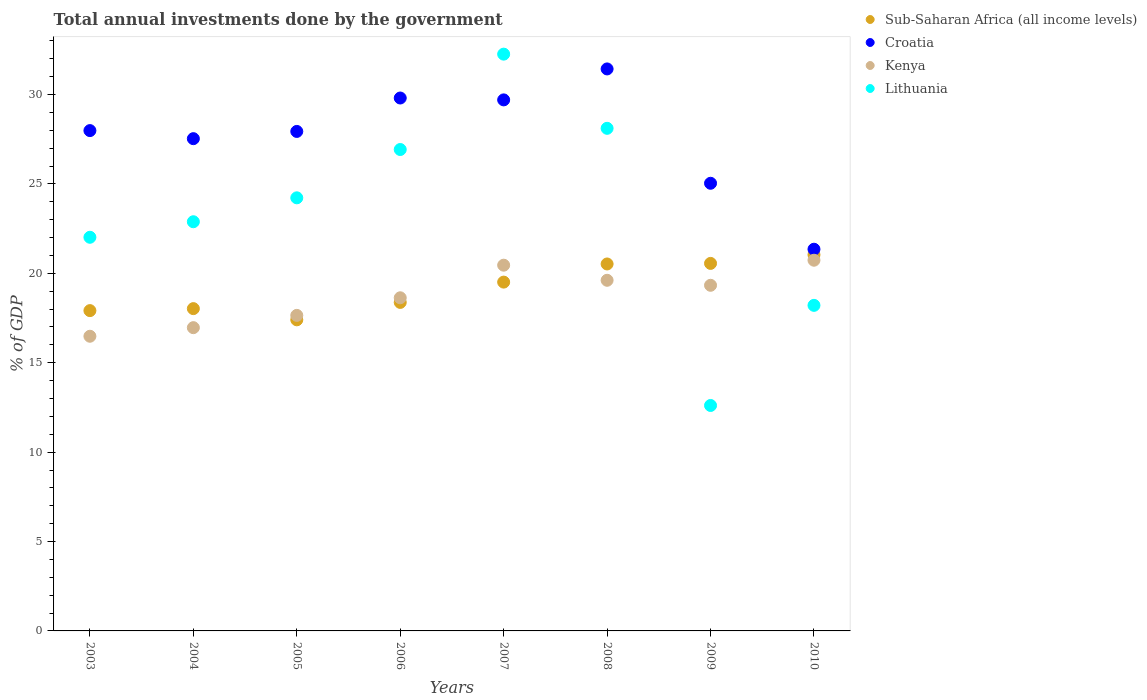How many different coloured dotlines are there?
Provide a short and direct response. 4. What is the total annual investments done by the government in Kenya in 2007?
Your response must be concise. 20.46. Across all years, what is the maximum total annual investments done by the government in Croatia?
Ensure brevity in your answer.  31.43. Across all years, what is the minimum total annual investments done by the government in Lithuania?
Make the answer very short. 12.61. In which year was the total annual investments done by the government in Lithuania maximum?
Give a very brief answer. 2007. What is the total total annual investments done by the government in Lithuania in the graph?
Ensure brevity in your answer.  187.25. What is the difference between the total annual investments done by the government in Croatia in 2008 and that in 2009?
Ensure brevity in your answer.  6.4. What is the difference between the total annual investments done by the government in Lithuania in 2003 and the total annual investments done by the government in Kenya in 2008?
Your answer should be compact. 2.41. What is the average total annual investments done by the government in Croatia per year?
Your answer should be compact. 27.6. In the year 2010, what is the difference between the total annual investments done by the government in Sub-Saharan Africa (all income levels) and total annual investments done by the government in Kenya?
Give a very brief answer. 0.3. What is the ratio of the total annual investments done by the government in Sub-Saharan Africa (all income levels) in 2006 to that in 2010?
Offer a very short reply. 0.87. Is the total annual investments done by the government in Kenya in 2005 less than that in 2008?
Your answer should be compact. Yes. Is the difference between the total annual investments done by the government in Sub-Saharan Africa (all income levels) in 2004 and 2008 greater than the difference between the total annual investments done by the government in Kenya in 2004 and 2008?
Offer a very short reply. Yes. What is the difference between the highest and the second highest total annual investments done by the government in Lithuania?
Make the answer very short. 4.15. What is the difference between the highest and the lowest total annual investments done by the government in Lithuania?
Offer a very short reply. 19.65. In how many years, is the total annual investments done by the government in Lithuania greater than the average total annual investments done by the government in Lithuania taken over all years?
Your answer should be compact. 4. Is it the case that in every year, the sum of the total annual investments done by the government in Kenya and total annual investments done by the government in Sub-Saharan Africa (all income levels)  is greater than the sum of total annual investments done by the government in Lithuania and total annual investments done by the government in Croatia?
Offer a very short reply. No. Is it the case that in every year, the sum of the total annual investments done by the government in Sub-Saharan Africa (all income levels) and total annual investments done by the government in Kenya  is greater than the total annual investments done by the government in Croatia?
Your answer should be very brief. Yes. Does the total annual investments done by the government in Lithuania monotonically increase over the years?
Provide a succinct answer. No. Is the total annual investments done by the government in Lithuania strictly less than the total annual investments done by the government in Croatia over the years?
Provide a succinct answer. No. How many years are there in the graph?
Make the answer very short. 8. Does the graph contain grids?
Provide a succinct answer. No. Where does the legend appear in the graph?
Give a very brief answer. Top right. How are the legend labels stacked?
Offer a very short reply. Vertical. What is the title of the graph?
Ensure brevity in your answer.  Total annual investments done by the government. Does "Sint Maarten (Dutch part)" appear as one of the legend labels in the graph?
Your answer should be very brief. No. What is the label or title of the Y-axis?
Your response must be concise. % of GDP. What is the % of GDP of Sub-Saharan Africa (all income levels) in 2003?
Provide a succinct answer. 17.92. What is the % of GDP of Croatia in 2003?
Ensure brevity in your answer.  27.99. What is the % of GDP of Kenya in 2003?
Make the answer very short. 16.48. What is the % of GDP in Lithuania in 2003?
Offer a very short reply. 22.02. What is the % of GDP in Sub-Saharan Africa (all income levels) in 2004?
Offer a very short reply. 18.03. What is the % of GDP of Croatia in 2004?
Your response must be concise. 27.53. What is the % of GDP of Kenya in 2004?
Offer a terse response. 16.96. What is the % of GDP in Lithuania in 2004?
Ensure brevity in your answer.  22.89. What is the % of GDP of Sub-Saharan Africa (all income levels) in 2005?
Keep it short and to the point. 17.4. What is the % of GDP in Croatia in 2005?
Keep it short and to the point. 27.94. What is the % of GDP in Kenya in 2005?
Make the answer very short. 17.65. What is the % of GDP of Lithuania in 2005?
Provide a succinct answer. 24.22. What is the % of GDP of Sub-Saharan Africa (all income levels) in 2006?
Give a very brief answer. 18.37. What is the % of GDP of Croatia in 2006?
Keep it short and to the point. 29.81. What is the % of GDP of Kenya in 2006?
Ensure brevity in your answer.  18.63. What is the % of GDP of Lithuania in 2006?
Provide a short and direct response. 26.93. What is the % of GDP in Sub-Saharan Africa (all income levels) in 2007?
Give a very brief answer. 19.51. What is the % of GDP in Croatia in 2007?
Your response must be concise. 29.7. What is the % of GDP of Kenya in 2007?
Provide a short and direct response. 20.46. What is the % of GDP in Lithuania in 2007?
Keep it short and to the point. 32.26. What is the % of GDP of Sub-Saharan Africa (all income levels) in 2008?
Offer a very short reply. 20.53. What is the % of GDP in Croatia in 2008?
Your answer should be very brief. 31.43. What is the % of GDP in Kenya in 2008?
Make the answer very short. 19.61. What is the % of GDP of Lithuania in 2008?
Provide a short and direct response. 28.11. What is the % of GDP of Sub-Saharan Africa (all income levels) in 2009?
Your answer should be very brief. 20.56. What is the % of GDP in Croatia in 2009?
Give a very brief answer. 25.04. What is the % of GDP in Kenya in 2009?
Give a very brief answer. 19.33. What is the % of GDP of Lithuania in 2009?
Your answer should be very brief. 12.61. What is the % of GDP of Sub-Saharan Africa (all income levels) in 2010?
Keep it short and to the point. 21.04. What is the % of GDP in Croatia in 2010?
Offer a terse response. 21.35. What is the % of GDP in Kenya in 2010?
Provide a succinct answer. 20.73. What is the % of GDP of Lithuania in 2010?
Your answer should be very brief. 18.21. Across all years, what is the maximum % of GDP of Sub-Saharan Africa (all income levels)?
Ensure brevity in your answer.  21.04. Across all years, what is the maximum % of GDP of Croatia?
Your response must be concise. 31.43. Across all years, what is the maximum % of GDP of Kenya?
Your answer should be compact. 20.73. Across all years, what is the maximum % of GDP in Lithuania?
Offer a very short reply. 32.26. Across all years, what is the minimum % of GDP of Sub-Saharan Africa (all income levels)?
Offer a terse response. 17.4. Across all years, what is the minimum % of GDP in Croatia?
Your answer should be very brief. 21.35. Across all years, what is the minimum % of GDP of Kenya?
Your answer should be compact. 16.48. Across all years, what is the minimum % of GDP of Lithuania?
Ensure brevity in your answer.  12.61. What is the total % of GDP in Sub-Saharan Africa (all income levels) in the graph?
Provide a short and direct response. 153.35. What is the total % of GDP of Croatia in the graph?
Offer a very short reply. 220.79. What is the total % of GDP in Kenya in the graph?
Your answer should be very brief. 149.87. What is the total % of GDP of Lithuania in the graph?
Provide a succinct answer. 187.25. What is the difference between the % of GDP of Sub-Saharan Africa (all income levels) in 2003 and that in 2004?
Provide a short and direct response. -0.11. What is the difference between the % of GDP in Croatia in 2003 and that in 2004?
Give a very brief answer. 0.45. What is the difference between the % of GDP of Kenya in 2003 and that in 2004?
Give a very brief answer. -0.48. What is the difference between the % of GDP in Lithuania in 2003 and that in 2004?
Offer a very short reply. -0.87. What is the difference between the % of GDP of Sub-Saharan Africa (all income levels) in 2003 and that in 2005?
Keep it short and to the point. 0.52. What is the difference between the % of GDP in Croatia in 2003 and that in 2005?
Provide a succinct answer. 0.05. What is the difference between the % of GDP of Kenya in 2003 and that in 2005?
Provide a succinct answer. -1.17. What is the difference between the % of GDP in Lithuania in 2003 and that in 2005?
Your answer should be very brief. -2.21. What is the difference between the % of GDP of Sub-Saharan Africa (all income levels) in 2003 and that in 2006?
Your answer should be very brief. -0.46. What is the difference between the % of GDP of Croatia in 2003 and that in 2006?
Make the answer very short. -1.82. What is the difference between the % of GDP in Kenya in 2003 and that in 2006?
Your answer should be very brief. -2.15. What is the difference between the % of GDP in Lithuania in 2003 and that in 2006?
Keep it short and to the point. -4.91. What is the difference between the % of GDP of Sub-Saharan Africa (all income levels) in 2003 and that in 2007?
Make the answer very short. -1.59. What is the difference between the % of GDP in Croatia in 2003 and that in 2007?
Ensure brevity in your answer.  -1.72. What is the difference between the % of GDP in Kenya in 2003 and that in 2007?
Your response must be concise. -3.97. What is the difference between the % of GDP of Lithuania in 2003 and that in 2007?
Offer a very short reply. -10.24. What is the difference between the % of GDP of Sub-Saharan Africa (all income levels) in 2003 and that in 2008?
Make the answer very short. -2.61. What is the difference between the % of GDP in Croatia in 2003 and that in 2008?
Your response must be concise. -3.45. What is the difference between the % of GDP in Kenya in 2003 and that in 2008?
Keep it short and to the point. -3.13. What is the difference between the % of GDP in Lithuania in 2003 and that in 2008?
Provide a succinct answer. -6.09. What is the difference between the % of GDP in Sub-Saharan Africa (all income levels) in 2003 and that in 2009?
Offer a very short reply. -2.64. What is the difference between the % of GDP of Croatia in 2003 and that in 2009?
Offer a terse response. 2.95. What is the difference between the % of GDP in Kenya in 2003 and that in 2009?
Your response must be concise. -2.85. What is the difference between the % of GDP in Lithuania in 2003 and that in 2009?
Keep it short and to the point. 9.41. What is the difference between the % of GDP in Sub-Saharan Africa (all income levels) in 2003 and that in 2010?
Give a very brief answer. -3.12. What is the difference between the % of GDP of Croatia in 2003 and that in 2010?
Offer a terse response. 6.64. What is the difference between the % of GDP of Kenya in 2003 and that in 2010?
Offer a terse response. -4.25. What is the difference between the % of GDP in Lithuania in 2003 and that in 2010?
Offer a terse response. 3.81. What is the difference between the % of GDP in Sub-Saharan Africa (all income levels) in 2004 and that in 2005?
Your answer should be compact. 0.63. What is the difference between the % of GDP of Croatia in 2004 and that in 2005?
Offer a very short reply. -0.4. What is the difference between the % of GDP of Kenya in 2004 and that in 2005?
Give a very brief answer. -0.69. What is the difference between the % of GDP in Lithuania in 2004 and that in 2005?
Keep it short and to the point. -1.34. What is the difference between the % of GDP of Sub-Saharan Africa (all income levels) in 2004 and that in 2006?
Offer a terse response. -0.35. What is the difference between the % of GDP of Croatia in 2004 and that in 2006?
Give a very brief answer. -2.27. What is the difference between the % of GDP of Kenya in 2004 and that in 2006?
Offer a terse response. -1.67. What is the difference between the % of GDP in Lithuania in 2004 and that in 2006?
Make the answer very short. -4.04. What is the difference between the % of GDP of Sub-Saharan Africa (all income levels) in 2004 and that in 2007?
Offer a terse response. -1.48. What is the difference between the % of GDP in Croatia in 2004 and that in 2007?
Your response must be concise. -2.17. What is the difference between the % of GDP in Kenya in 2004 and that in 2007?
Provide a succinct answer. -3.49. What is the difference between the % of GDP of Lithuania in 2004 and that in 2007?
Make the answer very short. -9.37. What is the difference between the % of GDP of Sub-Saharan Africa (all income levels) in 2004 and that in 2008?
Give a very brief answer. -2.5. What is the difference between the % of GDP in Croatia in 2004 and that in 2008?
Offer a terse response. -3.9. What is the difference between the % of GDP of Kenya in 2004 and that in 2008?
Offer a terse response. -2.65. What is the difference between the % of GDP in Lithuania in 2004 and that in 2008?
Offer a very short reply. -5.23. What is the difference between the % of GDP in Sub-Saharan Africa (all income levels) in 2004 and that in 2009?
Offer a terse response. -2.53. What is the difference between the % of GDP in Croatia in 2004 and that in 2009?
Make the answer very short. 2.5. What is the difference between the % of GDP of Kenya in 2004 and that in 2009?
Your answer should be compact. -2.37. What is the difference between the % of GDP in Lithuania in 2004 and that in 2009?
Your answer should be very brief. 10.28. What is the difference between the % of GDP in Sub-Saharan Africa (all income levels) in 2004 and that in 2010?
Offer a terse response. -3.01. What is the difference between the % of GDP in Croatia in 2004 and that in 2010?
Ensure brevity in your answer.  6.18. What is the difference between the % of GDP of Kenya in 2004 and that in 2010?
Your answer should be compact. -3.77. What is the difference between the % of GDP of Lithuania in 2004 and that in 2010?
Your answer should be very brief. 4.68. What is the difference between the % of GDP of Sub-Saharan Africa (all income levels) in 2005 and that in 2006?
Give a very brief answer. -0.97. What is the difference between the % of GDP of Croatia in 2005 and that in 2006?
Keep it short and to the point. -1.87. What is the difference between the % of GDP of Kenya in 2005 and that in 2006?
Your response must be concise. -0.98. What is the difference between the % of GDP of Lithuania in 2005 and that in 2006?
Offer a very short reply. -2.7. What is the difference between the % of GDP in Sub-Saharan Africa (all income levels) in 2005 and that in 2007?
Offer a very short reply. -2.11. What is the difference between the % of GDP of Croatia in 2005 and that in 2007?
Your response must be concise. -1.76. What is the difference between the % of GDP in Kenya in 2005 and that in 2007?
Keep it short and to the point. -2.81. What is the difference between the % of GDP in Lithuania in 2005 and that in 2007?
Provide a succinct answer. -8.04. What is the difference between the % of GDP of Sub-Saharan Africa (all income levels) in 2005 and that in 2008?
Make the answer very short. -3.12. What is the difference between the % of GDP in Croatia in 2005 and that in 2008?
Your answer should be compact. -3.5. What is the difference between the % of GDP in Kenya in 2005 and that in 2008?
Make the answer very short. -1.96. What is the difference between the % of GDP in Lithuania in 2005 and that in 2008?
Keep it short and to the point. -3.89. What is the difference between the % of GDP in Sub-Saharan Africa (all income levels) in 2005 and that in 2009?
Keep it short and to the point. -3.16. What is the difference between the % of GDP of Croatia in 2005 and that in 2009?
Make the answer very short. 2.9. What is the difference between the % of GDP of Kenya in 2005 and that in 2009?
Provide a succinct answer. -1.68. What is the difference between the % of GDP of Lithuania in 2005 and that in 2009?
Your answer should be compact. 11.62. What is the difference between the % of GDP in Sub-Saharan Africa (all income levels) in 2005 and that in 2010?
Your answer should be compact. -3.64. What is the difference between the % of GDP of Croatia in 2005 and that in 2010?
Offer a terse response. 6.59. What is the difference between the % of GDP in Kenya in 2005 and that in 2010?
Make the answer very short. -3.09. What is the difference between the % of GDP in Lithuania in 2005 and that in 2010?
Keep it short and to the point. 6.01. What is the difference between the % of GDP of Sub-Saharan Africa (all income levels) in 2006 and that in 2007?
Offer a terse response. -1.14. What is the difference between the % of GDP in Croatia in 2006 and that in 2007?
Your answer should be very brief. 0.1. What is the difference between the % of GDP of Kenya in 2006 and that in 2007?
Your answer should be compact. -1.82. What is the difference between the % of GDP of Lithuania in 2006 and that in 2007?
Give a very brief answer. -5.33. What is the difference between the % of GDP in Sub-Saharan Africa (all income levels) in 2006 and that in 2008?
Make the answer very short. -2.15. What is the difference between the % of GDP in Croatia in 2006 and that in 2008?
Provide a succinct answer. -1.63. What is the difference between the % of GDP of Kenya in 2006 and that in 2008?
Give a very brief answer. -0.98. What is the difference between the % of GDP of Lithuania in 2006 and that in 2008?
Give a very brief answer. -1.19. What is the difference between the % of GDP in Sub-Saharan Africa (all income levels) in 2006 and that in 2009?
Give a very brief answer. -2.18. What is the difference between the % of GDP in Croatia in 2006 and that in 2009?
Offer a terse response. 4.77. What is the difference between the % of GDP in Kenya in 2006 and that in 2009?
Make the answer very short. -0.7. What is the difference between the % of GDP in Lithuania in 2006 and that in 2009?
Your answer should be very brief. 14.32. What is the difference between the % of GDP of Sub-Saharan Africa (all income levels) in 2006 and that in 2010?
Offer a terse response. -2.66. What is the difference between the % of GDP of Croatia in 2006 and that in 2010?
Offer a terse response. 8.46. What is the difference between the % of GDP of Kenya in 2006 and that in 2010?
Offer a very short reply. -2.1. What is the difference between the % of GDP of Lithuania in 2006 and that in 2010?
Provide a short and direct response. 8.72. What is the difference between the % of GDP in Sub-Saharan Africa (all income levels) in 2007 and that in 2008?
Provide a succinct answer. -1.01. What is the difference between the % of GDP in Croatia in 2007 and that in 2008?
Your answer should be very brief. -1.73. What is the difference between the % of GDP of Kenya in 2007 and that in 2008?
Your answer should be compact. 0.84. What is the difference between the % of GDP in Lithuania in 2007 and that in 2008?
Your answer should be compact. 4.15. What is the difference between the % of GDP in Sub-Saharan Africa (all income levels) in 2007 and that in 2009?
Give a very brief answer. -1.05. What is the difference between the % of GDP of Croatia in 2007 and that in 2009?
Provide a succinct answer. 4.66. What is the difference between the % of GDP in Kenya in 2007 and that in 2009?
Offer a terse response. 1.12. What is the difference between the % of GDP in Lithuania in 2007 and that in 2009?
Provide a short and direct response. 19.65. What is the difference between the % of GDP of Sub-Saharan Africa (all income levels) in 2007 and that in 2010?
Your response must be concise. -1.53. What is the difference between the % of GDP in Croatia in 2007 and that in 2010?
Give a very brief answer. 8.35. What is the difference between the % of GDP of Kenya in 2007 and that in 2010?
Keep it short and to the point. -0.28. What is the difference between the % of GDP in Lithuania in 2007 and that in 2010?
Offer a terse response. 14.05. What is the difference between the % of GDP in Sub-Saharan Africa (all income levels) in 2008 and that in 2009?
Your response must be concise. -0.03. What is the difference between the % of GDP of Croatia in 2008 and that in 2009?
Keep it short and to the point. 6.4. What is the difference between the % of GDP of Kenya in 2008 and that in 2009?
Your answer should be very brief. 0.28. What is the difference between the % of GDP of Lithuania in 2008 and that in 2009?
Provide a short and direct response. 15.5. What is the difference between the % of GDP in Sub-Saharan Africa (all income levels) in 2008 and that in 2010?
Provide a short and direct response. -0.51. What is the difference between the % of GDP in Croatia in 2008 and that in 2010?
Offer a terse response. 10.08. What is the difference between the % of GDP of Kenya in 2008 and that in 2010?
Give a very brief answer. -1.12. What is the difference between the % of GDP in Lithuania in 2008 and that in 2010?
Provide a succinct answer. 9.9. What is the difference between the % of GDP of Sub-Saharan Africa (all income levels) in 2009 and that in 2010?
Give a very brief answer. -0.48. What is the difference between the % of GDP in Croatia in 2009 and that in 2010?
Your answer should be compact. 3.69. What is the difference between the % of GDP of Kenya in 2009 and that in 2010?
Your response must be concise. -1.4. What is the difference between the % of GDP of Lithuania in 2009 and that in 2010?
Provide a short and direct response. -5.6. What is the difference between the % of GDP of Sub-Saharan Africa (all income levels) in 2003 and the % of GDP of Croatia in 2004?
Your answer should be very brief. -9.62. What is the difference between the % of GDP of Sub-Saharan Africa (all income levels) in 2003 and the % of GDP of Kenya in 2004?
Ensure brevity in your answer.  0.95. What is the difference between the % of GDP of Sub-Saharan Africa (all income levels) in 2003 and the % of GDP of Lithuania in 2004?
Your answer should be very brief. -4.97. What is the difference between the % of GDP of Croatia in 2003 and the % of GDP of Kenya in 2004?
Your response must be concise. 11.02. What is the difference between the % of GDP in Croatia in 2003 and the % of GDP in Lithuania in 2004?
Ensure brevity in your answer.  5.1. What is the difference between the % of GDP of Kenya in 2003 and the % of GDP of Lithuania in 2004?
Your answer should be very brief. -6.41. What is the difference between the % of GDP of Sub-Saharan Africa (all income levels) in 2003 and the % of GDP of Croatia in 2005?
Make the answer very short. -10.02. What is the difference between the % of GDP in Sub-Saharan Africa (all income levels) in 2003 and the % of GDP in Kenya in 2005?
Make the answer very short. 0.27. What is the difference between the % of GDP of Sub-Saharan Africa (all income levels) in 2003 and the % of GDP of Lithuania in 2005?
Your response must be concise. -6.31. What is the difference between the % of GDP in Croatia in 2003 and the % of GDP in Kenya in 2005?
Your response must be concise. 10.34. What is the difference between the % of GDP of Croatia in 2003 and the % of GDP of Lithuania in 2005?
Ensure brevity in your answer.  3.76. What is the difference between the % of GDP of Kenya in 2003 and the % of GDP of Lithuania in 2005?
Give a very brief answer. -7.74. What is the difference between the % of GDP in Sub-Saharan Africa (all income levels) in 2003 and the % of GDP in Croatia in 2006?
Offer a terse response. -11.89. What is the difference between the % of GDP of Sub-Saharan Africa (all income levels) in 2003 and the % of GDP of Kenya in 2006?
Offer a terse response. -0.72. What is the difference between the % of GDP in Sub-Saharan Africa (all income levels) in 2003 and the % of GDP in Lithuania in 2006?
Offer a very short reply. -9.01. What is the difference between the % of GDP of Croatia in 2003 and the % of GDP of Kenya in 2006?
Your answer should be very brief. 9.35. What is the difference between the % of GDP of Croatia in 2003 and the % of GDP of Lithuania in 2006?
Offer a very short reply. 1.06. What is the difference between the % of GDP in Kenya in 2003 and the % of GDP in Lithuania in 2006?
Offer a very short reply. -10.44. What is the difference between the % of GDP in Sub-Saharan Africa (all income levels) in 2003 and the % of GDP in Croatia in 2007?
Your answer should be compact. -11.79. What is the difference between the % of GDP of Sub-Saharan Africa (all income levels) in 2003 and the % of GDP of Kenya in 2007?
Your answer should be compact. -2.54. What is the difference between the % of GDP in Sub-Saharan Africa (all income levels) in 2003 and the % of GDP in Lithuania in 2007?
Make the answer very short. -14.35. What is the difference between the % of GDP in Croatia in 2003 and the % of GDP in Kenya in 2007?
Your answer should be compact. 7.53. What is the difference between the % of GDP in Croatia in 2003 and the % of GDP in Lithuania in 2007?
Ensure brevity in your answer.  -4.28. What is the difference between the % of GDP in Kenya in 2003 and the % of GDP in Lithuania in 2007?
Provide a succinct answer. -15.78. What is the difference between the % of GDP in Sub-Saharan Africa (all income levels) in 2003 and the % of GDP in Croatia in 2008?
Make the answer very short. -13.52. What is the difference between the % of GDP in Sub-Saharan Africa (all income levels) in 2003 and the % of GDP in Kenya in 2008?
Provide a succinct answer. -1.7. What is the difference between the % of GDP of Sub-Saharan Africa (all income levels) in 2003 and the % of GDP of Lithuania in 2008?
Provide a succinct answer. -10.2. What is the difference between the % of GDP in Croatia in 2003 and the % of GDP in Kenya in 2008?
Provide a short and direct response. 8.37. What is the difference between the % of GDP of Croatia in 2003 and the % of GDP of Lithuania in 2008?
Ensure brevity in your answer.  -0.13. What is the difference between the % of GDP of Kenya in 2003 and the % of GDP of Lithuania in 2008?
Keep it short and to the point. -11.63. What is the difference between the % of GDP of Sub-Saharan Africa (all income levels) in 2003 and the % of GDP of Croatia in 2009?
Offer a terse response. -7.12. What is the difference between the % of GDP in Sub-Saharan Africa (all income levels) in 2003 and the % of GDP in Kenya in 2009?
Provide a short and direct response. -1.42. What is the difference between the % of GDP of Sub-Saharan Africa (all income levels) in 2003 and the % of GDP of Lithuania in 2009?
Ensure brevity in your answer.  5.31. What is the difference between the % of GDP in Croatia in 2003 and the % of GDP in Kenya in 2009?
Your response must be concise. 8.65. What is the difference between the % of GDP of Croatia in 2003 and the % of GDP of Lithuania in 2009?
Provide a short and direct response. 15.38. What is the difference between the % of GDP in Kenya in 2003 and the % of GDP in Lithuania in 2009?
Your response must be concise. 3.87. What is the difference between the % of GDP in Sub-Saharan Africa (all income levels) in 2003 and the % of GDP in Croatia in 2010?
Offer a terse response. -3.43. What is the difference between the % of GDP of Sub-Saharan Africa (all income levels) in 2003 and the % of GDP of Kenya in 2010?
Your response must be concise. -2.82. What is the difference between the % of GDP in Sub-Saharan Africa (all income levels) in 2003 and the % of GDP in Lithuania in 2010?
Ensure brevity in your answer.  -0.29. What is the difference between the % of GDP in Croatia in 2003 and the % of GDP in Kenya in 2010?
Provide a short and direct response. 7.25. What is the difference between the % of GDP in Croatia in 2003 and the % of GDP in Lithuania in 2010?
Your answer should be very brief. 9.78. What is the difference between the % of GDP of Kenya in 2003 and the % of GDP of Lithuania in 2010?
Your response must be concise. -1.73. What is the difference between the % of GDP of Sub-Saharan Africa (all income levels) in 2004 and the % of GDP of Croatia in 2005?
Give a very brief answer. -9.91. What is the difference between the % of GDP in Sub-Saharan Africa (all income levels) in 2004 and the % of GDP in Kenya in 2005?
Offer a terse response. 0.38. What is the difference between the % of GDP in Sub-Saharan Africa (all income levels) in 2004 and the % of GDP in Lithuania in 2005?
Provide a short and direct response. -6.2. What is the difference between the % of GDP of Croatia in 2004 and the % of GDP of Kenya in 2005?
Make the answer very short. 9.88. What is the difference between the % of GDP of Croatia in 2004 and the % of GDP of Lithuania in 2005?
Give a very brief answer. 3.31. What is the difference between the % of GDP of Kenya in 2004 and the % of GDP of Lithuania in 2005?
Provide a short and direct response. -7.26. What is the difference between the % of GDP of Sub-Saharan Africa (all income levels) in 2004 and the % of GDP of Croatia in 2006?
Your answer should be compact. -11.78. What is the difference between the % of GDP in Sub-Saharan Africa (all income levels) in 2004 and the % of GDP in Kenya in 2006?
Ensure brevity in your answer.  -0.61. What is the difference between the % of GDP of Sub-Saharan Africa (all income levels) in 2004 and the % of GDP of Lithuania in 2006?
Offer a very short reply. -8.9. What is the difference between the % of GDP of Croatia in 2004 and the % of GDP of Kenya in 2006?
Provide a succinct answer. 8.9. What is the difference between the % of GDP in Croatia in 2004 and the % of GDP in Lithuania in 2006?
Provide a short and direct response. 0.61. What is the difference between the % of GDP in Kenya in 2004 and the % of GDP in Lithuania in 2006?
Make the answer very short. -9.96. What is the difference between the % of GDP of Sub-Saharan Africa (all income levels) in 2004 and the % of GDP of Croatia in 2007?
Ensure brevity in your answer.  -11.68. What is the difference between the % of GDP in Sub-Saharan Africa (all income levels) in 2004 and the % of GDP in Kenya in 2007?
Ensure brevity in your answer.  -2.43. What is the difference between the % of GDP in Sub-Saharan Africa (all income levels) in 2004 and the % of GDP in Lithuania in 2007?
Your answer should be very brief. -14.23. What is the difference between the % of GDP of Croatia in 2004 and the % of GDP of Kenya in 2007?
Offer a very short reply. 7.08. What is the difference between the % of GDP of Croatia in 2004 and the % of GDP of Lithuania in 2007?
Provide a succinct answer. -4.73. What is the difference between the % of GDP of Kenya in 2004 and the % of GDP of Lithuania in 2007?
Provide a short and direct response. -15.3. What is the difference between the % of GDP of Sub-Saharan Africa (all income levels) in 2004 and the % of GDP of Croatia in 2008?
Ensure brevity in your answer.  -13.41. What is the difference between the % of GDP in Sub-Saharan Africa (all income levels) in 2004 and the % of GDP in Kenya in 2008?
Provide a succinct answer. -1.59. What is the difference between the % of GDP in Sub-Saharan Africa (all income levels) in 2004 and the % of GDP in Lithuania in 2008?
Offer a very short reply. -10.09. What is the difference between the % of GDP of Croatia in 2004 and the % of GDP of Kenya in 2008?
Your answer should be very brief. 7.92. What is the difference between the % of GDP of Croatia in 2004 and the % of GDP of Lithuania in 2008?
Ensure brevity in your answer.  -0.58. What is the difference between the % of GDP in Kenya in 2004 and the % of GDP in Lithuania in 2008?
Ensure brevity in your answer.  -11.15. What is the difference between the % of GDP in Sub-Saharan Africa (all income levels) in 2004 and the % of GDP in Croatia in 2009?
Your response must be concise. -7.01. What is the difference between the % of GDP of Sub-Saharan Africa (all income levels) in 2004 and the % of GDP of Kenya in 2009?
Make the answer very short. -1.31. What is the difference between the % of GDP of Sub-Saharan Africa (all income levels) in 2004 and the % of GDP of Lithuania in 2009?
Your response must be concise. 5.42. What is the difference between the % of GDP in Croatia in 2004 and the % of GDP in Kenya in 2009?
Your answer should be compact. 8.2. What is the difference between the % of GDP of Croatia in 2004 and the % of GDP of Lithuania in 2009?
Keep it short and to the point. 14.92. What is the difference between the % of GDP in Kenya in 2004 and the % of GDP in Lithuania in 2009?
Make the answer very short. 4.35. What is the difference between the % of GDP in Sub-Saharan Africa (all income levels) in 2004 and the % of GDP in Croatia in 2010?
Offer a very short reply. -3.32. What is the difference between the % of GDP in Sub-Saharan Africa (all income levels) in 2004 and the % of GDP in Kenya in 2010?
Your response must be concise. -2.71. What is the difference between the % of GDP of Sub-Saharan Africa (all income levels) in 2004 and the % of GDP of Lithuania in 2010?
Your answer should be very brief. -0.18. What is the difference between the % of GDP in Croatia in 2004 and the % of GDP in Kenya in 2010?
Keep it short and to the point. 6.8. What is the difference between the % of GDP in Croatia in 2004 and the % of GDP in Lithuania in 2010?
Provide a short and direct response. 9.32. What is the difference between the % of GDP of Kenya in 2004 and the % of GDP of Lithuania in 2010?
Keep it short and to the point. -1.25. What is the difference between the % of GDP in Sub-Saharan Africa (all income levels) in 2005 and the % of GDP in Croatia in 2006?
Your answer should be very brief. -12.41. What is the difference between the % of GDP in Sub-Saharan Africa (all income levels) in 2005 and the % of GDP in Kenya in 2006?
Provide a short and direct response. -1.23. What is the difference between the % of GDP in Sub-Saharan Africa (all income levels) in 2005 and the % of GDP in Lithuania in 2006?
Give a very brief answer. -9.53. What is the difference between the % of GDP of Croatia in 2005 and the % of GDP of Kenya in 2006?
Provide a short and direct response. 9.3. What is the difference between the % of GDP in Croatia in 2005 and the % of GDP in Lithuania in 2006?
Ensure brevity in your answer.  1.01. What is the difference between the % of GDP of Kenya in 2005 and the % of GDP of Lithuania in 2006?
Make the answer very short. -9.28. What is the difference between the % of GDP in Sub-Saharan Africa (all income levels) in 2005 and the % of GDP in Croatia in 2007?
Your answer should be very brief. -12.3. What is the difference between the % of GDP of Sub-Saharan Africa (all income levels) in 2005 and the % of GDP of Kenya in 2007?
Provide a succinct answer. -3.06. What is the difference between the % of GDP of Sub-Saharan Africa (all income levels) in 2005 and the % of GDP of Lithuania in 2007?
Provide a succinct answer. -14.86. What is the difference between the % of GDP in Croatia in 2005 and the % of GDP in Kenya in 2007?
Your answer should be compact. 7.48. What is the difference between the % of GDP of Croatia in 2005 and the % of GDP of Lithuania in 2007?
Offer a very short reply. -4.32. What is the difference between the % of GDP in Kenya in 2005 and the % of GDP in Lithuania in 2007?
Give a very brief answer. -14.61. What is the difference between the % of GDP in Sub-Saharan Africa (all income levels) in 2005 and the % of GDP in Croatia in 2008?
Provide a succinct answer. -14.03. What is the difference between the % of GDP of Sub-Saharan Africa (all income levels) in 2005 and the % of GDP of Kenya in 2008?
Keep it short and to the point. -2.21. What is the difference between the % of GDP in Sub-Saharan Africa (all income levels) in 2005 and the % of GDP in Lithuania in 2008?
Offer a very short reply. -10.71. What is the difference between the % of GDP in Croatia in 2005 and the % of GDP in Kenya in 2008?
Give a very brief answer. 8.33. What is the difference between the % of GDP of Croatia in 2005 and the % of GDP of Lithuania in 2008?
Ensure brevity in your answer.  -0.17. What is the difference between the % of GDP of Kenya in 2005 and the % of GDP of Lithuania in 2008?
Your answer should be compact. -10.46. What is the difference between the % of GDP of Sub-Saharan Africa (all income levels) in 2005 and the % of GDP of Croatia in 2009?
Your answer should be very brief. -7.64. What is the difference between the % of GDP of Sub-Saharan Africa (all income levels) in 2005 and the % of GDP of Kenya in 2009?
Give a very brief answer. -1.93. What is the difference between the % of GDP of Sub-Saharan Africa (all income levels) in 2005 and the % of GDP of Lithuania in 2009?
Make the answer very short. 4.79. What is the difference between the % of GDP of Croatia in 2005 and the % of GDP of Kenya in 2009?
Your answer should be very brief. 8.61. What is the difference between the % of GDP in Croatia in 2005 and the % of GDP in Lithuania in 2009?
Provide a succinct answer. 15.33. What is the difference between the % of GDP in Kenya in 2005 and the % of GDP in Lithuania in 2009?
Give a very brief answer. 5.04. What is the difference between the % of GDP of Sub-Saharan Africa (all income levels) in 2005 and the % of GDP of Croatia in 2010?
Keep it short and to the point. -3.95. What is the difference between the % of GDP of Sub-Saharan Africa (all income levels) in 2005 and the % of GDP of Kenya in 2010?
Your answer should be compact. -3.33. What is the difference between the % of GDP of Sub-Saharan Africa (all income levels) in 2005 and the % of GDP of Lithuania in 2010?
Provide a short and direct response. -0.81. What is the difference between the % of GDP in Croatia in 2005 and the % of GDP in Kenya in 2010?
Keep it short and to the point. 7.2. What is the difference between the % of GDP in Croatia in 2005 and the % of GDP in Lithuania in 2010?
Offer a very short reply. 9.73. What is the difference between the % of GDP in Kenya in 2005 and the % of GDP in Lithuania in 2010?
Keep it short and to the point. -0.56. What is the difference between the % of GDP in Sub-Saharan Africa (all income levels) in 2006 and the % of GDP in Croatia in 2007?
Your response must be concise. -11.33. What is the difference between the % of GDP in Sub-Saharan Africa (all income levels) in 2006 and the % of GDP in Kenya in 2007?
Your answer should be compact. -2.08. What is the difference between the % of GDP in Sub-Saharan Africa (all income levels) in 2006 and the % of GDP in Lithuania in 2007?
Ensure brevity in your answer.  -13.89. What is the difference between the % of GDP of Croatia in 2006 and the % of GDP of Kenya in 2007?
Provide a succinct answer. 9.35. What is the difference between the % of GDP of Croatia in 2006 and the % of GDP of Lithuania in 2007?
Your answer should be very brief. -2.45. What is the difference between the % of GDP in Kenya in 2006 and the % of GDP in Lithuania in 2007?
Your answer should be compact. -13.63. What is the difference between the % of GDP of Sub-Saharan Africa (all income levels) in 2006 and the % of GDP of Croatia in 2008?
Give a very brief answer. -13.06. What is the difference between the % of GDP of Sub-Saharan Africa (all income levels) in 2006 and the % of GDP of Kenya in 2008?
Give a very brief answer. -1.24. What is the difference between the % of GDP of Sub-Saharan Africa (all income levels) in 2006 and the % of GDP of Lithuania in 2008?
Your answer should be compact. -9.74. What is the difference between the % of GDP of Croatia in 2006 and the % of GDP of Kenya in 2008?
Provide a short and direct response. 10.2. What is the difference between the % of GDP of Croatia in 2006 and the % of GDP of Lithuania in 2008?
Offer a terse response. 1.7. What is the difference between the % of GDP in Kenya in 2006 and the % of GDP in Lithuania in 2008?
Your answer should be compact. -9.48. What is the difference between the % of GDP of Sub-Saharan Africa (all income levels) in 2006 and the % of GDP of Croatia in 2009?
Your answer should be compact. -6.66. What is the difference between the % of GDP of Sub-Saharan Africa (all income levels) in 2006 and the % of GDP of Kenya in 2009?
Ensure brevity in your answer.  -0.96. What is the difference between the % of GDP of Sub-Saharan Africa (all income levels) in 2006 and the % of GDP of Lithuania in 2009?
Offer a terse response. 5.77. What is the difference between the % of GDP in Croatia in 2006 and the % of GDP in Kenya in 2009?
Your response must be concise. 10.48. What is the difference between the % of GDP in Croatia in 2006 and the % of GDP in Lithuania in 2009?
Offer a very short reply. 17.2. What is the difference between the % of GDP of Kenya in 2006 and the % of GDP of Lithuania in 2009?
Provide a short and direct response. 6.02. What is the difference between the % of GDP in Sub-Saharan Africa (all income levels) in 2006 and the % of GDP in Croatia in 2010?
Keep it short and to the point. -2.98. What is the difference between the % of GDP of Sub-Saharan Africa (all income levels) in 2006 and the % of GDP of Kenya in 2010?
Offer a very short reply. -2.36. What is the difference between the % of GDP in Sub-Saharan Africa (all income levels) in 2006 and the % of GDP in Lithuania in 2010?
Ensure brevity in your answer.  0.16. What is the difference between the % of GDP of Croatia in 2006 and the % of GDP of Kenya in 2010?
Provide a succinct answer. 9.07. What is the difference between the % of GDP in Croatia in 2006 and the % of GDP in Lithuania in 2010?
Provide a short and direct response. 11.6. What is the difference between the % of GDP in Kenya in 2006 and the % of GDP in Lithuania in 2010?
Keep it short and to the point. 0.42. What is the difference between the % of GDP in Sub-Saharan Africa (all income levels) in 2007 and the % of GDP in Croatia in 2008?
Keep it short and to the point. -11.92. What is the difference between the % of GDP of Sub-Saharan Africa (all income levels) in 2007 and the % of GDP of Kenya in 2008?
Offer a very short reply. -0.1. What is the difference between the % of GDP in Sub-Saharan Africa (all income levels) in 2007 and the % of GDP in Lithuania in 2008?
Give a very brief answer. -8.6. What is the difference between the % of GDP of Croatia in 2007 and the % of GDP of Kenya in 2008?
Your answer should be very brief. 10.09. What is the difference between the % of GDP in Croatia in 2007 and the % of GDP in Lithuania in 2008?
Give a very brief answer. 1.59. What is the difference between the % of GDP of Kenya in 2007 and the % of GDP of Lithuania in 2008?
Your response must be concise. -7.66. What is the difference between the % of GDP of Sub-Saharan Africa (all income levels) in 2007 and the % of GDP of Croatia in 2009?
Offer a terse response. -5.53. What is the difference between the % of GDP in Sub-Saharan Africa (all income levels) in 2007 and the % of GDP in Kenya in 2009?
Give a very brief answer. 0.18. What is the difference between the % of GDP in Sub-Saharan Africa (all income levels) in 2007 and the % of GDP in Lithuania in 2009?
Provide a succinct answer. 6.9. What is the difference between the % of GDP of Croatia in 2007 and the % of GDP of Kenya in 2009?
Your response must be concise. 10.37. What is the difference between the % of GDP of Croatia in 2007 and the % of GDP of Lithuania in 2009?
Your answer should be compact. 17.09. What is the difference between the % of GDP in Kenya in 2007 and the % of GDP in Lithuania in 2009?
Ensure brevity in your answer.  7.85. What is the difference between the % of GDP of Sub-Saharan Africa (all income levels) in 2007 and the % of GDP of Croatia in 2010?
Your response must be concise. -1.84. What is the difference between the % of GDP of Sub-Saharan Africa (all income levels) in 2007 and the % of GDP of Kenya in 2010?
Your response must be concise. -1.22. What is the difference between the % of GDP of Sub-Saharan Africa (all income levels) in 2007 and the % of GDP of Lithuania in 2010?
Your response must be concise. 1.3. What is the difference between the % of GDP in Croatia in 2007 and the % of GDP in Kenya in 2010?
Offer a terse response. 8.97. What is the difference between the % of GDP of Croatia in 2007 and the % of GDP of Lithuania in 2010?
Give a very brief answer. 11.49. What is the difference between the % of GDP in Kenya in 2007 and the % of GDP in Lithuania in 2010?
Make the answer very short. 2.25. What is the difference between the % of GDP of Sub-Saharan Africa (all income levels) in 2008 and the % of GDP of Croatia in 2009?
Provide a short and direct response. -4.51. What is the difference between the % of GDP in Sub-Saharan Africa (all income levels) in 2008 and the % of GDP in Kenya in 2009?
Your answer should be compact. 1.19. What is the difference between the % of GDP in Sub-Saharan Africa (all income levels) in 2008 and the % of GDP in Lithuania in 2009?
Your answer should be compact. 7.92. What is the difference between the % of GDP of Croatia in 2008 and the % of GDP of Kenya in 2009?
Offer a very short reply. 12.1. What is the difference between the % of GDP of Croatia in 2008 and the % of GDP of Lithuania in 2009?
Ensure brevity in your answer.  18.82. What is the difference between the % of GDP in Kenya in 2008 and the % of GDP in Lithuania in 2009?
Your response must be concise. 7. What is the difference between the % of GDP of Sub-Saharan Africa (all income levels) in 2008 and the % of GDP of Croatia in 2010?
Offer a very short reply. -0.82. What is the difference between the % of GDP in Sub-Saharan Africa (all income levels) in 2008 and the % of GDP in Kenya in 2010?
Make the answer very short. -0.21. What is the difference between the % of GDP in Sub-Saharan Africa (all income levels) in 2008 and the % of GDP in Lithuania in 2010?
Offer a very short reply. 2.32. What is the difference between the % of GDP in Croatia in 2008 and the % of GDP in Kenya in 2010?
Offer a terse response. 10.7. What is the difference between the % of GDP in Croatia in 2008 and the % of GDP in Lithuania in 2010?
Give a very brief answer. 13.22. What is the difference between the % of GDP of Kenya in 2008 and the % of GDP of Lithuania in 2010?
Your response must be concise. 1.4. What is the difference between the % of GDP of Sub-Saharan Africa (all income levels) in 2009 and the % of GDP of Croatia in 2010?
Your response must be concise. -0.79. What is the difference between the % of GDP in Sub-Saharan Africa (all income levels) in 2009 and the % of GDP in Kenya in 2010?
Offer a terse response. -0.18. What is the difference between the % of GDP of Sub-Saharan Africa (all income levels) in 2009 and the % of GDP of Lithuania in 2010?
Make the answer very short. 2.35. What is the difference between the % of GDP in Croatia in 2009 and the % of GDP in Kenya in 2010?
Give a very brief answer. 4.3. What is the difference between the % of GDP of Croatia in 2009 and the % of GDP of Lithuania in 2010?
Make the answer very short. 6.83. What is the difference between the % of GDP of Kenya in 2009 and the % of GDP of Lithuania in 2010?
Give a very brief answer. 1.12. What is the average % of GDP of Sub-Saharan Africa (all income levels) per year?
Your response must be concise. 19.17. What is the average % of GDP of Croatia per year?
Keep it short and to the point. 27.6. What is the average % of GDP of Kenya per year?
Provide a succinct answer. 18.73. What is the average % of GDP in Lithuania per year?
Keep it short and to the point. 23.41. In the year 2003, what is the difference between the % of GDP in Sub-Saharan Africa (all income levels) and % of GDP in Croatia?
Your response must be concise. -10.07. In the year 2003, what is the difference between the % of GDP of Sub-Saharan Africa (all income levels) and % of GDP of Kenya?
Your answer should be very brief. 1.43. In the year 2003, what is the difference between the % of GDP of Sub-Saharan Africa (all income levels) and % of GDP of Lithuania?
Offer a very short reply. -4.1. In the year 2003, what is the difference between the % of GDP in Croatia and % of GDP in Kenya?
Your answer should be very brief. 11.5. In the year 2003, what is the difference between the % of GDP in Croatia and % of GDP in Lithuania?
Your answer should be very brief. 5.97. In the year 2003, what is the difference between the % of GDP of Kenya and % of GDP of Lithuania?
Offer a very short reply. -5.54. In the year 2004, what is the difference between the % of GDP of Sub-Saharan Africa (all income levels) and % of GDP of Croatia?
Your answer should be compact. -9.51. In the year 2004, what is the difference between the % of GDP of Sub-Saharan Africa (all income levels) and % of GDP of Kenya?
Your answer should be very brief. 1.06. In the year 2004, what is the difference between the % of GDP of Sub-Saharan Africa (all income levels) and % of GDP of Lithuania?
Provide a short and direct response. -4.86. In the year 2004, what is the difference between the % of GDP of Croatia and % of GDP of Kenya?
Give a very brief answer. 10.57. In the year 2004, what is the difference between the % of GDP in Croatia and % of GDP in Lithuania?
Your answer should be very brief. 4.65. In the year 2004, what is the difference between the % of GDP in Kenya and % of GDP in Lithuania?
Offer a very short reply. -5.92. In the year 2005, what is the difference between the % of GDP in Sub-Saharan Africa (all income levels) and % of GDP in Croatia?
Provide a succinct answer. -10.54. In the year 2005, what is the difference between the % of GDP of Sub-Saharan Africa (all income levels) and % of GDP of Kenya?
Offer a terse response. -0.25. In the year 2005, what is the difference between the % of GDP in Sub-Saharan Africa (all income levels) and % of GDP in Lithuania?
Give a very brief answer. -6.82. In the year 2005, what is the difference between the % of GDP of Croatia and % of GDP of Kenya?
Make the answer very short. 10.29. In the year 2005, what is the difference between the % of GDP in Croatia and % of GDP in Lithuania?
Ensure brevity in your answer.  3.71. In the year 2005, what is the difference between the % of GDP in Kenya and % of GDP in Lithuania?
Offer a terse response. -6.58. In the year 2006, what is the difference between the % of GDP in Sub-Saharan Africa (all income levels) and % of GDP in Croatia?
Your answer should be very brief. -11.43. In the year 2006, what is the difference between the % of GDP in Sub-Saharan Africa (all income levels) and % of GDP in Kenya?
Provide a short and direct response. -0.26. In the year 2006, what is the difference between the % of GDP of Sub-Saharan Africa (all income levels) and % of GDP of Lithuania?
Your answer should be compact. -8.55. In the year 2006, what is the difference between the % of GDP in Croatia and % of GDP in Kenya?
Offer a very short reply. 11.17. In the year 2006, what is the difference between the % of GDP of Croatia and % of GDP of Lithuania?
Provide a succinct answer. 2.88. In the year 2006, what is the difference between the % of GDP of Kenya and % of GDP of Lithuania?
Give a very brief answer. -8.29. In the year 2007, what is the difference between the % of GDP of Sub-Saharan Africa (all income levels) and % of GDP of Croatia?
Offer a very short reply. -10.19. In the year 2007, what is the difference between the % of GDP of Sub-Saharan Africa (all income levels) and % of GDP of Kenya?
Ensure brevity in your answer.  -0.95. In the year 2007, what is the difference between the % of GDP of Sub-Saharan Africa (all income levels) and % of GDP of Lithuania?
Provide a short and direct response. -12.75. In the year 2007, what is the difference between the % of GDP in Croatia and % of GDP in Kenya?
Keep it short and to the point. 9.25. In the year 2007, what is the difference between the % of GDP of Croatia and % of GDP of Lithuania?
Offer a terse response. -2.56. In the year 2007, what is the difference between the % of GDP in Kenya and % of GDP in Lithuania?
Offer a very short reply. -11.8. In the year 2008, what is the difference between the % of GDP in Sub-Saharan Africa (all income levels) and % of GDP in Croatia?
Your answer should be very brief. -10.91. In the year 2008, what is the difference between the % of GDP in Sub-Saharan Africa (all income levels) and % of GDP in Kenya?
Keep it short and to the point. 0.91. In the year 2008, what is the difference between the % of GDP of Sub-Saharan Africa (all income levels) and % of GDP of Lithuania?
Offer a terse response. -7.59. In the year 2008, what is the difference between the % of GDP in Croatia and % of GDP in Kenya?
Your answer should be very brief. 11.82. In the year 2008, what is the difference between the % of GDP in Croatia and % of GDP in Lithuania?
Offer a terse response. 3.32. In the year 2008, what is the difference between the % of GDP of Kenya and % of GDP of Lithuania?
Your answer should be compact. -8.5. In the year 2009, what is the difference between the % of GDP in Sub-Saharan Africa (all income levels) and % of GDP in Croatia?
Provide a short and direct response. -4.48. In the year 2009, what is the difference between the % of GDP in Sub-Saharan Africa (all income levels) and % of GDP in Kenya?
Keep it short and to the point. 1.22. In the year 2009, what is the difference between the % of GDP of Sub-Saharan Africa (all income levels) and % of GDP of Lithuania?
Your answer should be very brief. 7.95. In the year 2009, what is the difference between the % of GDP in Croatia and % of GDP in Kenya?
Your response must be concise. 5.71. In the year 2009, what is the difference between the % of GDP in Croatia and % of GDP in Lithuania?
Provide a short and direct response. 12.43. In the year 2009, what is the difference between the % of GDP of Kenya and % of GDP of Lithuania?
Provide a short and direct response. 6.72. In the year 2010, what is the difference between the % of GDP in Sub-Saharan Africa (all income levels) and % of GDP in Croatia?
Provide a succinct answer. -0.31. In the year 2010, what is the difference between the % of GDP in Sub-Saharan Africa (all income levels) and % of GDP in Kenya?
Provide a short and direct response. 0.3. In the year 2010, what is the difference between the % of GDP of Sub-Saharan Africa (all income levels) and % of GDP of Lithuania?
Make the answer very short. 2.83. In the year 2010, what is the difference between the % of GDP of Croatia and % of GDP of Kenya?
Ensure brevity in your answer.  0.62. In the year 2010, what is the difference between the % of GDP in Croatia and % of GDP in Lithuania?
Ensure brevity in your answer.  3.14. In the year 2010, what is the difference between the % of GDP of Kenya and % of GDP of Lithuania?
Offer a very short reply. 2.52. What is the ratio of the % of GDP of Sub-Saharan Africa (all income levels) in 2003 to that in 2004?
Make the answer very short. 0.99. What is the ratio of the % of GDP in Croatia in 2003 to that in 2004?
Make the answer very short. 1.02. What is the ratio of the % of GDP in Kenya in 2003 to that in 2004?
Make the answer very short. 0.97. What is the ratio of the % of GDP in Lithuania in 2003 to that in 2004?
Your response must be concise. 0.96. What is the ratio of the % of GDP of Sub-Saharan Africa (all income levels) in 2003 to that in 2005?
Offer a terse response. 1.03. What is the ratio of the % of GDP in Croatia in 2003 to that in 2005?
Keep it short and to the point. 1. What is the ratio of the % of GDP of Kenya in 2003 to that in 2005?
Provide a succinct answer. 0.93. What is the ratio of the % of GDP in Lithuania in 2003 to that in 2005?
Give a very brief answer. 0.91. What is the ratio of the % of GDP of Croatia in 2003 to that in 2006?
Make the answer very short. 0.94. What is the ratio of the % of GDP of Kenya in 2003 to that in 2006?
Offer a terse response. 0.88. What is the ratio of the % of GDP of Lithuania in 2003 to that in 2006?
Make the answer very short. 0.82. What is the ratio of the % of GDP of Sub-Saharan Africa (all income levels) in 2003 to that in 2007?
Your answer should be very brief. 0.92. What is the ratio of the % of GDP of Croatia in 2003 to that in 2007?
Offer a terse response. 0.94. What is the ratio of the % of GDP in Kenya in 2003 to that in 2007?
Your answer should be very brief. 0.81. What is the ratio of the % of GDP in Lithuania in 2003 to that in 2007?
Provide a short and direct response. 0.68. What is the ratio of the % of GDP of Sub-Saharan Africa (all income levels) in 2003 to that in 2008?
Give a very brief answer. 0.87. What is the ratio of the % of GDP in Croatia in 2003 to that in 2008?
Your response must be concise. 0.89. What is the ratio of the % of GDP in Kenya in 2003 to that in 2008?
Offer a very short reply. 0.84. What is the ratio of the % of GDP of Lithuania in 2003 to that in 2008?
Offer a terse response. 0.78. What is the ratio of the % of GDP of Sub-Saharan Africa (all income levels) in 2003 to that in 2009?
Ensure brevity in your answer.  0.87. What is the ratio of the % of GDP in Croatia in 2003 to that in 2009?
Your answer should be very brief. 1.12. What is the ratio of the % of GDP in Kenya in 2003 to that in 2009?
Provide a succinct answer. 0.85. What is the ratio of the % of GDP of Lithuania in 2003 to that in 2009?
Make the answer very short. 1.75. What is the ratio of the % of GDP in Sub-Saharan Africa (all income levels) in 2003 to that in 2010?
Give a very brief answer. 0.85. What is the ratio of the % of GDP in Croatia in 2003 to that in 2010?
Make the answer very short. 1.31. What is the ratio of the % of GDP in Kenya in 2003 to that in 2010?
Ensure brevity in your answer.  0.79. What is the ratio of the % of GDP in Lithuania in 2003 to that in 2010?
Ensure brevity in your answer.  1.21. What is the ratio of the % of GDP of Sub-Saharan Africa (all income levels) in 2004 to that in 2005?
Give a very brief answer. 1.04. What is the ratio of the % of GDP of Croatia in 2004 to that in 2005?
Your answer should be compact. 0.99. What is the ratio of the % of GDP in Kenya in 2004 to that in 2005?
Offer a very short reply. 0.96. What is the ratio of the % of GDP of Lithuania in 2004 to that in 2005?
Your answer should be very brief. 0.94. What is the ratio of the % of GDP of Sub-Saharan Africa (all income levels) in 2004 to that in 2006?
Keep it short and to the point. 0.98. What is the ratio of the % of GDP of Croatia in 2004 to that in 2006?
Your answer should be very brief. 0.92. What is the ratio of the % of GDP in Kenya in 2004 to that in 2006?
Ensure brevity in your answer.  0.91. What is the ratio of the % of GDP of Sub-Saharan Africa (all income levels) in 2004 to that in 2007?
Offer a very short reply. 0.92. What is the ratio of the % of GDP in Croatia in 2004 to that in 2007?
Provide a short and direct response. 0.93. What is the ratio of the % of GDP in Kenya in 2004 to that in 2007?
Make the answer very short. 0.83. What is the ratio of the % of GDP in Lithuania in 2004 to that in 2007?
Offer a very short reply. 0.71. What is the ratio of the % of GDP of Sub-Saharan Africa (all income levels) in 2004 to that in 2008?
Your response must be concise. 0.88. What is the ratio of the % of GDP in Croatia in 2004 to that in 2008?
Make the answer very short. 0.88. What is the ratio of the % of GDP in Kenya in 2004 to that in 2008?
Your response must be concise. 0.86. What is the ratio of the % of GDP of Lithuania in 2004 to that in 2008?
Offer a very short reply. 0.81. What is the ratio of the % of GDP in Sub-Saharan Africa (all income levels) in 2004 to that in 2009?
Keep it short and to the point. 0.88. What is the ratio of the % of GDP in Croatia in 2004 to that in 2009?
Keep it short and to the point. 1.1. What is the ratio of the % of GDP of Kenya in 2004 to that in 2009?
Ensure brevity in your answer.  0.88. What is the ratio of the % of GDP of Lithuania in 2004 to that in 2009?
Your response must be concise. 1.81. What is the ratio of the % of GDP of Sub-Saharan Africa (all income levels) in 2004 to that in 2010?
Provide a short and direct response. 0.86. What is the ratio of the % of GDP of Croatia in 2004 to that in 2010?
Offer a terse response. 1.29. What is the ratio of the % of GDP of Kenya in 2004 to that in 2010?
Provide a short and direct response. 0.82. What is the ratio of the % of GDP of Lithuania in 2004 to that in 2010?
Make the answer very short. 1.26. What is the ratio of the % of GDP in Sub-Saharan Africa (all income levels) in 2005 to that in 2006?
Your answer should be compact. 0.95. What is the ratio of the % of GDP of Croatia in 2005 to that in 2006?
Your answer should be very brief. 0.94. What is the ratio of the % of GDP of Kenya in 2005 to that in 2006?
Offer a terse response. 0.95. What is the ratio of the % of GDP in Lithuania in 2005 to that in 2006?
Provide a short and direct response. 0.9. What is the ratio of the % of GDP in Sub-Saharan Africa (all income levels) in 2005 to that in 2007?
Offer a terse response. 0.89. What is the ratio of the % of GDP of Croatia in 2005 to that in 2007?
Provide a short and direct response. 0.94. What is the ratio of the % of GDP in Kenya in 2005 to that in 2007?
Offer a very short reply. 0.86. What is the ratio of the % of GDP in Lithuania in 2005 to that in 2007?
Provide a succinct answer. 0.75. What is the ratio of the % of GDP of Sub-Saharan Africa (all income levels) in 2005 to that in 2008?
Your answer should be very brief. 0.85. What is the ratio of the % of GDP in Croatia in 2005 to that in 2008?
Provide a short and direct response. 0.89. What is the ratio of the % of GDP in Kenya in 2005 to that in 2008?
Keep it short and to the point. 0.9. What is the ratio of the % of GDP in Lithuania in 2005 to that in 2008?
Your answer should be very brief. 0.86. What is the ratio of the % of GDP of Sub-Saharan Africa (all income levels) in 2005 to that in 2009?
Offer a very short reply. 0.85. What is the ratio of the % of GDP in Croatia in 2005 to that in 2009?
Provide a short and direct response. 1.12. What is the ratio of the % of GDP of Kenya in 2005 to that in 2009?
Offer a very short reply. 0.91. What is the ratio of the % of GDP of Lithuania in 2005 to that in 2009?
Ensure brevity in your answer.  1.92. What is the ratio of the % of GDP of Sub-Saharan Africa (all income levels) in 2005 to that in 2010?
Provide a succinct answer. 0.83. What is the ratio of the % of GDP in Croatia in 2005 to that in 2010?
Ensure brevity in your answer.  1.31. What is the ratio of the % of GDP in Kenya in 2005 to that in 2010?
Your answer should be compact. 0.85. What is the ratio of the % of GDP in Lithuania in 2005 to that in 2010?
Offer a terse response. 1.33. What is the ratio of the % of GDP of Sub-Saharan Africa (all income levels) in 2006 to that in 2007?
Your answer should be compact. 0.94. What is the ratio of the % of GDP of Croatia in 2006 to that in 2007?
Provide a succinct answer. 1. What is the ratio of the % of GDP in Kenya in 2006 to that in 2007?
Provide a succinct answer. 0.91. What is the ratio of the % of GDP of Lithuania in 2006 to that in 2007?
Your answer should be compact. 0.83. What is the ratio of the % of GDP in Sub-Saharan Africa (all income levels) in 2006 to that in 2008?
Provide a short and direct response. 0.9. What is the ratio of the % of GDP in Croatia in 2006 to that in 2008?
Give a very brief answer. 0.95. What is the ratio of the % of GDP of Kenya in 2006 to that in 2008?
Keep it short and to the point. 0.95. What is the ratio of the % of GDP in Lithuania in 2006 to that in 2008?
Make the answer very short. 0.96. What is the ratio of the % of GDP in Sub-Saharan Africa (all income levels) in 2006 to that in 2009?
Offer a very short reply. 0.89. What is the ratio of the % of GDP in Croatia in 2006 to that in 2009?
Keep it short and to the point. 1.19. What is the ratio of the % of GDP of Kenya in 2006 to that in 2009?
Provide a succinct answer. 0.96. What is the ratio of the % of GDP of Lithuania in 2006 to that in 2009?
Ensure brevity in your answer.  2.14. What is the ratio of the % of GDP in Sub-Saharan Africa (all income levels) in 2006 to that in 2010?
Keep it short and to the point. 0.87. What is the ratio of the % of GDP of Croatia in 2006 to that in 2010?
Give a very brief answer. 1.4. What is the ratio of the % of GDP in Kenya in 2006 to that in 2010?
Offer a terse response. 0.9. What is the ratio of the % of GDP of Lithuania in 2006 to that in 2010?
Your answer should be compact. 1.48. What is the ratio of the % of GDP in Sub-Saharan Africa (all income levels) in 2007 to that in 2008?
Keep it short and to the point. 0.95. What is the ratio of the % of GDP in Croatia in 2007 to that in 2008?
Keep it short and to the point. 0.94. What is the ratio of the % of GDP of Kenya in 2007 to that in 2008?
Provide a short and direct response. 1.04. What is the ratio of the % of GDP in Lithuania in 2007 to that in 2008?
Keep it short and to the point. 1.15. What is the ratio of the % of GDP in Sub-Saharan Africa (all income levels) in 2007 to that in 2009?
Make the answer very short. 0.95. What is the ratio of the % of GDP of Croatia in 2007 to that in 2009?
Your answer should be compact. 1.19. What is the ratio of the % of GDP of Kenya in 2007 to that in 2009?
Ensure brevity in your answer.  1.06. What is the ratio of the % of GDP of Lithuania in 2007 to that in 2009?
Provide a short and direct response. 2.56. What is the ratio of the % of GDP of Sub-Saharan Africa (all income levels) in 2007 to that in 2010?
Your answer should be very brief. 0.93. What is the ratio of the % of GDP in Croatia in 2007 to that in 2010?
Your response must be concise. 1.39. What is the ratio of the % of GDP in Kenya in 2007 to that in 2010?
Give a very brief answer. 0.99. What is the ratio of the % of GDP in Lithuania in 2007 to that in 2010?
Offer a very short reply. 1.77. What is the ratio of the % of GDP of Croatia in 2008 to that in 2009?
Keep it short and to the point. 1.26. What is the ratio of the % of GDP in Kenya in 2008 to that in 2009?
Provide a succinct answer. 1.01. What is the ratio of the % of GDP in Lithuania in 2008 to that in 2009?
Offer a very short reply. 2.23. What is the ratio of the % of GDP of Sub-Saharan Africa (all income levels) in 2008 to that in 2010?
Give a very brief answer. 0.98. What is the ratio of the % of GDP in Croatia in 2008 to that in 2010?
Keep it short and to the point. 1.47. What is the ratio of the % of GDP of Kenya in 2008 to that in 2010?
Make the answer very short. 0.95. What is the ratio of the % of GDP of Lithuania in 2008 to that in 2010?
Keep it short and to the point. 1.54. What is the ratio of the % of GDP of Sub-Saharan Africa (all income levels) in 2009 to that in 2010?
Make the answer very short. 0.98. What is the ratio of the % of GDP of Croatia in 2009 to that in 2010?
Provide a short and direct response. 1.17. What is the ratio of the % of GDP in Kenya in 2009 to that in 2010?
Offer a very short reply. 0.93. What is the ratio of the % of GDP in Lithuania in 2009 to that in 2010?
Your answer should be compact. 0.69. What is the difference between the highest and the second highest % of GDP in Sub-Saharan Africa (all income levels)?
Offer a terse response. 0.48. What is the difference between the highest and the second highest % of GDP in Croatia?
Offer a very short reply. 1.63. What is the difference between the highest and the second highest % of GDP in Kenya?
Make the answer very short. 0.28. What is the difference between the highest and the second highest % of GDP in Lithuania?
Give a very brief answer. 4.15. What is the difference between the highest and the lowest % of GDP of Sub-Saharan Africa (all income levels)?
Offer a terse response. 3.64. What is the difference between the highest and the lowest % of GDP of Croatia?
Make the answer very short. 10.08. What is the difference between the highest and the lowest % of GDP in Kenya?
Make the answer very short. 4.25. What is the difference between the highest and the lowest % of GDP of Lithuania?
Provide a succinct answer. 19.65. 